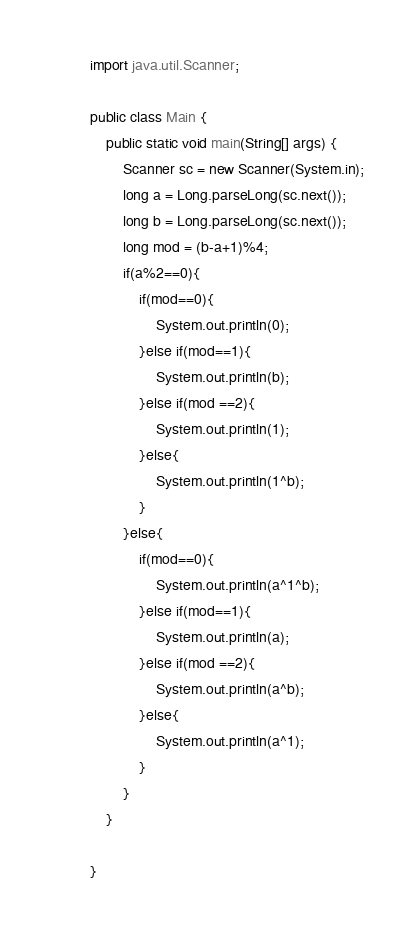<code> <loc_0><loc_0><loc_500><loc_500><_Java_>

import java.util.Scanner;

public class Main {
    public static void main(String[] args) {
        Scanner sc = new Scanner(System.in);
        long a = Long.parseLong(sc.next());
        long b = Long.parseLong(sc.next());
        long mod = (b-a+1)%4;
        if(a%2==0){
            if(mod==0){
                System.out.println(0);
            }else if(mod==1){
                System.out.println(b);
            }else if(mod ==2){
                System.out.println(1);
            }else{
                System.out.println(1^b);
            }
        }else{
            if(mod==0){
                System.out.println(a^1^b);
            }else if(mod==1){
                System.out.println(a);
            }else if(mod ==2){
                System.out.println(a^b);
            }else{
                System.out.println(a^1);
            }
        }
    }
    
}</code> 